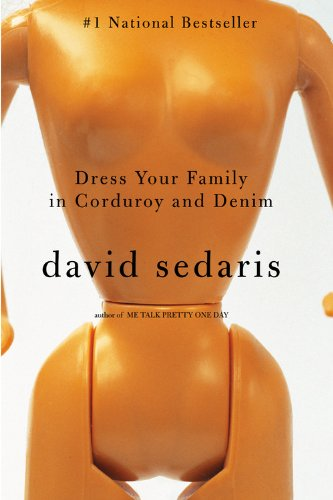Can you tell me about the visual design of the book cover? The cover features an abstract and slightly surreal design, with a mannequin in a bodysuit that lacks distinguishable facial features, emphasizing a focus on the body rather than identity. This quirky cover design reflects the unique and unconventional style of the essays within. 